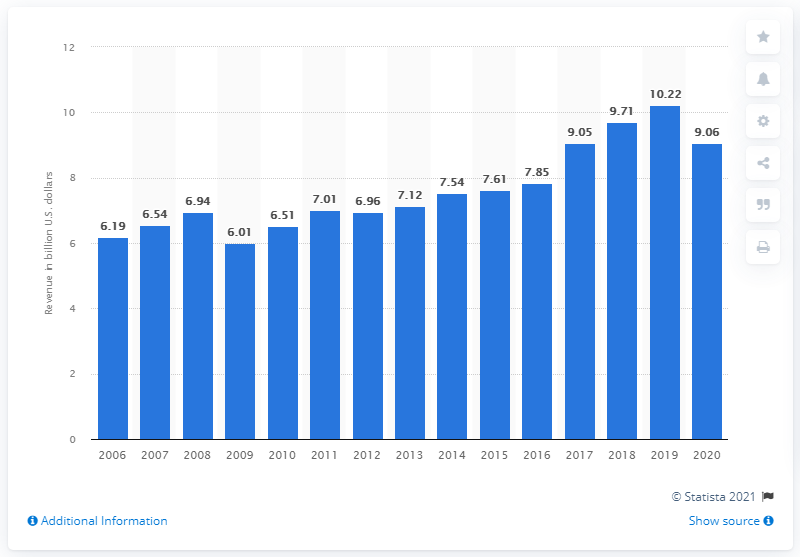Identify some key points in this picture. In 2020, Interpublic Group's global revenue was 9.06. Interpublic Group's global revenue in 2020 was $10.22 billion. 